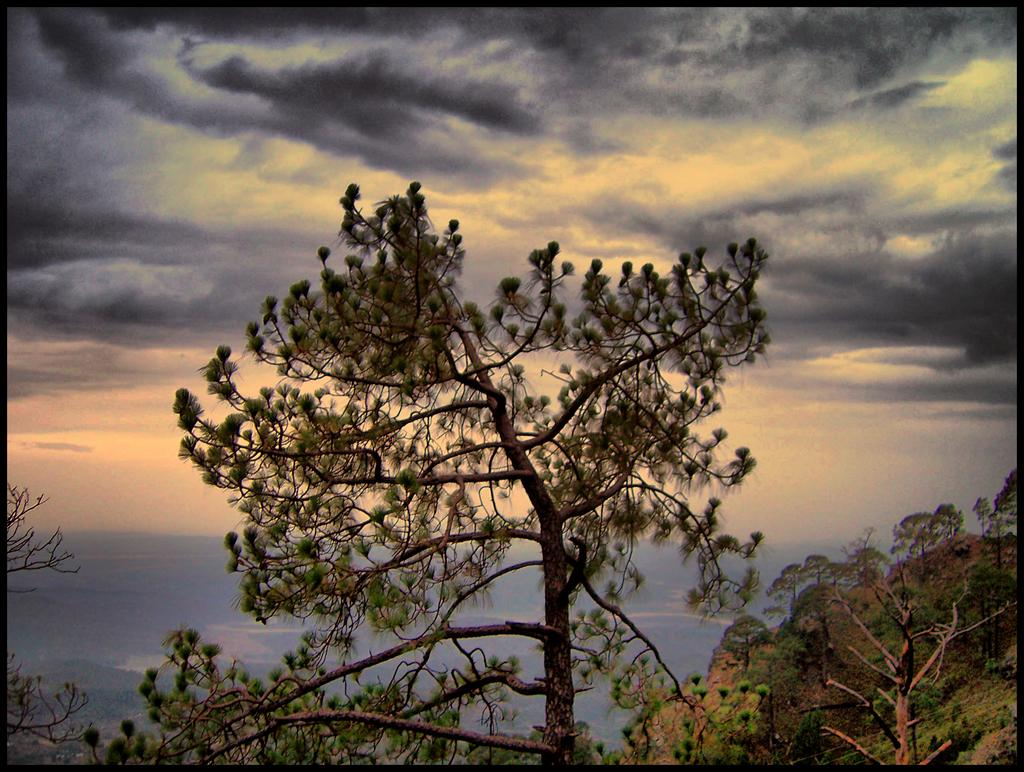What type of vegetation is present in the image? There are many trees in the image. What geographical feature can be seen on the right side of the image? There is a hill on the right side of the image. What is visible at the top of the image? The sky is visible at the top of the image}. What can be observed in the sky? Clouds are present in the sky. What type of sign can be seen on the front of the hill in the image? There is no sign present on the front of the hill in the image. What type of earth formation is visible on the front of the hill in the image? The provided facts do not mention any specific earth formations on the front of the hill in the image. 